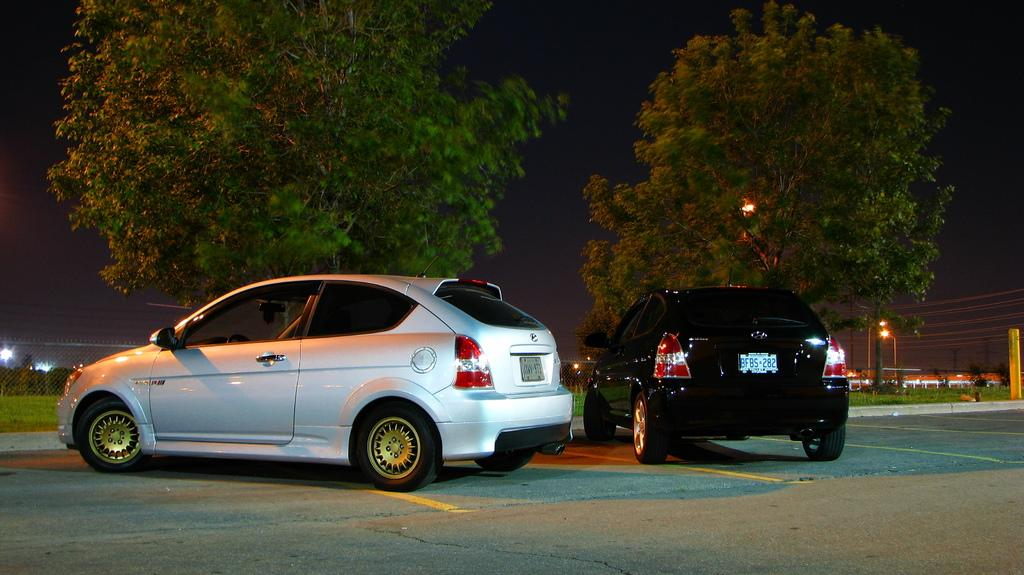How many cars are parked on the road in the image? There are two cars parked on the road in the image. What can be seen in the background of the image? In the background, there is a mesh, plants, grass, poles, trees, and lights. What is the general lighting condition in the image? The overall view appears to be dark. What type of leather is being distributed in the cellar in the image? There is no mention of leather or a cellar in the image; it features two parked cars and a background with various elements. 